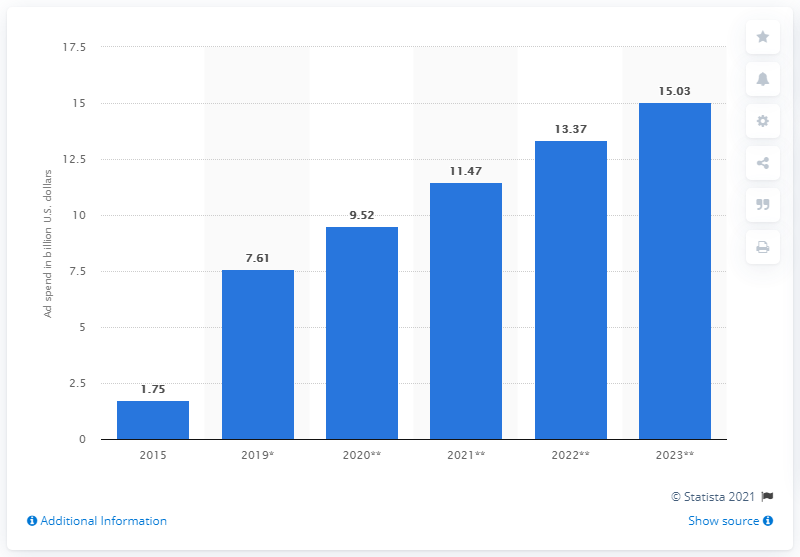Give some essential details in this illustration. In 2019, it was estimated that mobile video ad spending was approximately $7.61 billion. By 2023, mobile video ad spending was projected to reach $15.03 billion. 